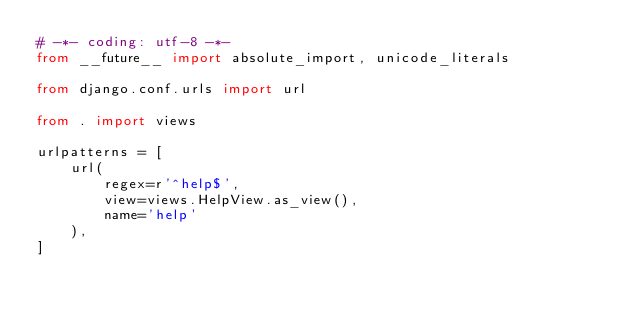<code> <loc_0><loc_0><loc_500><loc_500><_Python_># -*- coding: utf-8 -*-
from __future__ import absolute_import, unicode_literals

from django.conf.urls import url

from . import views

urlpatterns = [
    url(
        regex=r'^help$',
        view=views.HelpView.as_view(),
        name='help'
    ),
]
</code> 